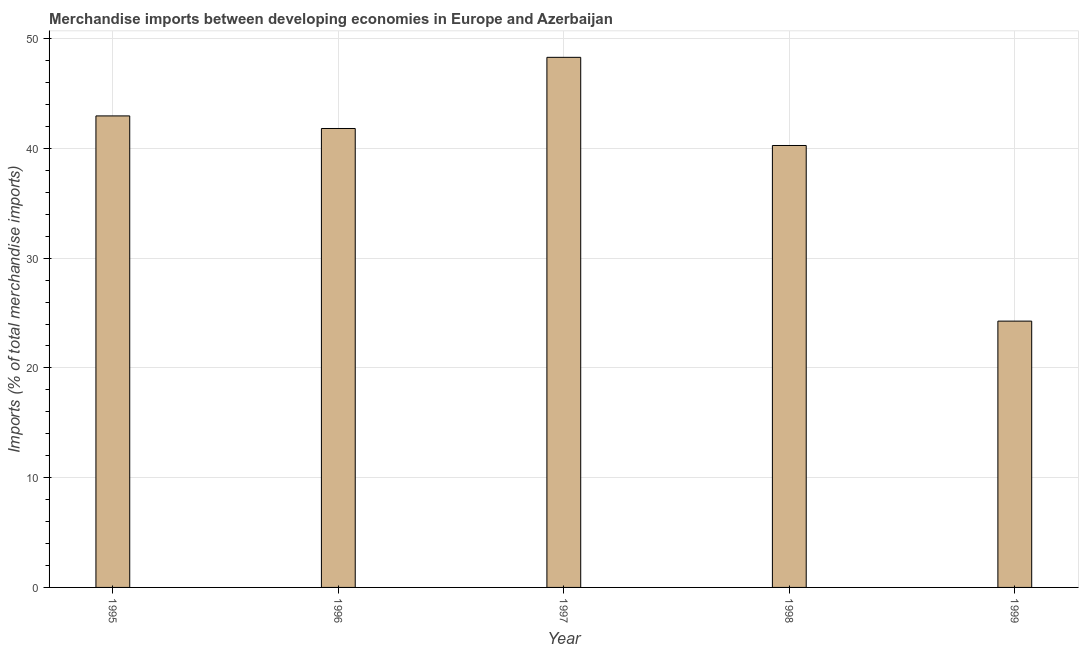Does the graph contain any zero values?
Make the answer very short. No. Does the graph contain grids?
Provide a short and direct response. Yes. What is the title of the graph?
Provide a succinct answer. Merchandise imports between developing economies in Europe and Azerbaijan. What is the label or title of the Y-axis?
Your response must be concise. Imports (% of total merchandise imports). What is the merchandise imports in 1998?
Keep it short and to the point. 40.27. Across all years, what is the maximum merchandise imports?
Your answer should be very brief. 48.3. Across all years, what is the minimum merchandise imports?
Ensure brevity in your answer.  24.27. What is the sum of the merchandise imports?
Offer a very short reply. 197.63. What is the difference between the merchandise imports in 1995 and 1997?
Your response must be concise. -5.34. What is the average merchandise imports per year?
Ensure brevity in your answer.  39.53. What is the median merchandise imports?
Provide a succinct answer. 41.82. In how many years, is the merchandise imports greater than 32 %?
Keep it short and to the point. 4. Do a majority of the years between 1999 and 1998 (inclusive) have merchandise imports greater than 6 %?
Give a very brief answer. No. What is the ratio of the merchandise imports in 1997 to that in 1999?
Offer a terse response. 1.99. Is the merchandise imports in 1995 less than that in 1997?
Offer a terse response. Yes. Is the difference between the merchandise imports in 1996 and 1997 greater than the difference between any two years?
Give a very brief answer. No. What is the difference between the highest and the second highest merchandise imports?
Your answer should be very brief. 5.34. What is the difference between the highest and the lowest merchandise imports?
Provide a short and direct response. 24.04. How many bars are there?
Give a very brief answer. 5. How many years are there in the graph?
Offer a terse response. 5. Are the values on the major ticks of Y-axis written in scientific E-notation?
Keep it short and to the point. No. What is the Imports (% of total merchandise imports) of 1995?
Make the answer very short. 42.97. What is the Imports (% of total merchandise imports) in 1996?
Your response must be concise. 41.82. What is the Imports (% of total merchandise imports) of 1997?
Give a very brief answer. 48.3. What is the Imports (% of total merchandise imports) in 1998?
Your response must be concise. 40.27. What is the Imports (% of total merchandise imports) of 1999?
Ensure brevity in your answer.  24.27. What is the difference between the Imports (% of total merchandise imports) in 1995 and 1996?
Your response must be concise. 1.15. What is the difference between the Imports (% of total merchandise imports) in 1995 and 1997?
Ensure brevity in your answer.  -5.34. What is the difference between the Imports (% of total merchandise imports) in 1995 and 1998?
Offer a terse response. 2.7. What is the difference between the Imports (% of total merchandise imports) in 1995 and 1999?
Offer a terse response. 18.7. What is the difference between the Imports (% of total merchandise imports) in 1996 and 1997?
Offer a very short reply. -6.48. What is the difference between the Imports (% of total merchandise imports) in 1996 and 1998?
Provide a succinct answer. 1.55. What is the difference between the Imports (% of total merchandise imports) in 1996 and 1999?
Offer a terse response. 17.55. What is the difference between the Imports (% of total merchandise imports) in 1997 and 1998?
Make the answer very short. 8.03. What is the difference between the Imports (% of total merchandise imports) in 1997 and 1999?
Your answer should be compact. 24.04. What is the difference between the Imports (% of total merchandise imports) in 1998 and 1999?
Your answer should be compact. 16. What is the ratio of the Imports (% of total merchandise imports) in 1995 to that in 1996?
Provide a succinct answer. 1.03. What is the ratio of the Imports (% of total merchandise imports) in 1995 to that in 1997?
Make the answer very short. 0.89. What is the ratio of the Imports (% of total merchandise imports) in 1995 to that in 1998?
Make the answer very short. 1.07. What is the ratio of the Imports (% of total merchandise imports) in 1995 to that in 1999?
Ensure brevity in your answer.  1.77. What is the ratio of the Imports (% of total merchandise imports) in 1996 to that in 1997?
Keep it short and to the point. 0.87. What is the ratio of the Imports (% of total merchandise imports) in 1996 to that in 1998?
Ensure brevity in your answer.  1.04. What is the ratio of the Imports (% of total merchandise imports) in 1996 to that in 1999?
Your response must be concise. 1.72. What is the ratio of the Imports (% of total merchandise imports) in 1997 to that in 1998?
Make the answer very short. 1.2. What is the ratio of the Imports (% of total merchandise imports) in 1997 to that in 1999?
Provide a short and direct response. 1.99. What is the ratio of the Imports (% of total merchandise imports) in 1998 to that in 1999?
Provide a succinct answer. 1.66. 